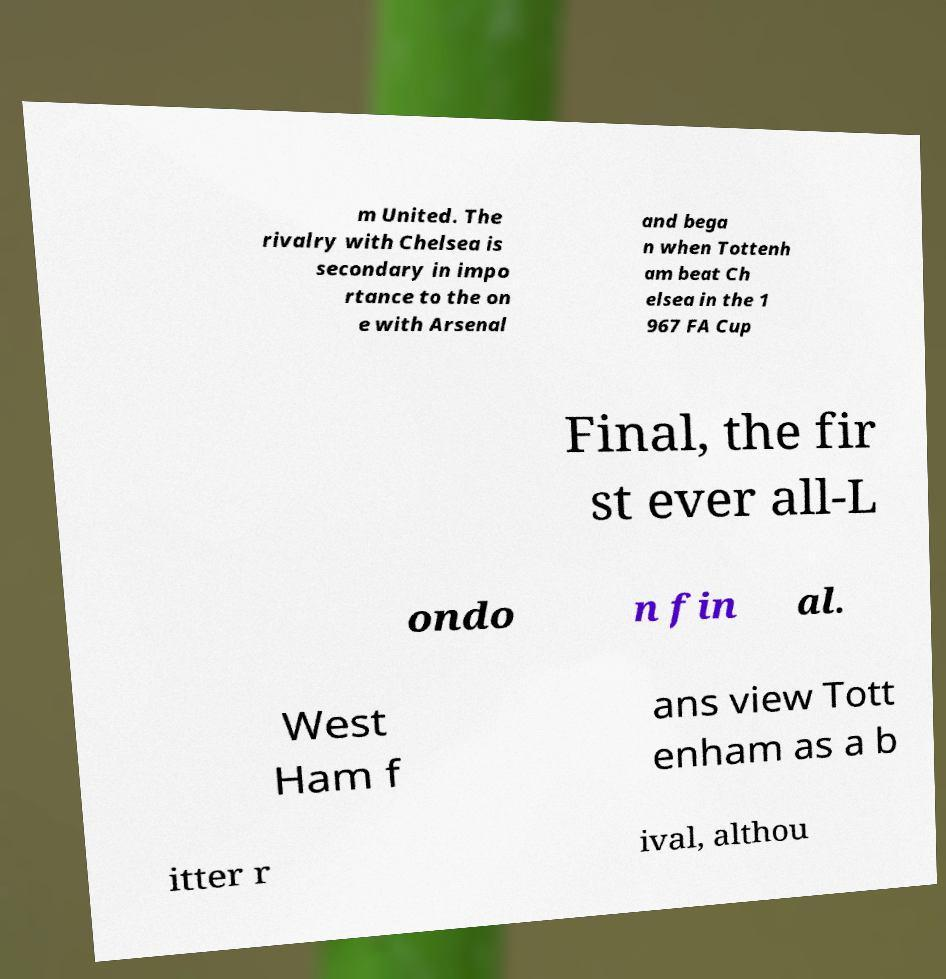What messages or text are displayed in this image? I need them in a readable, typed format. m United. The rivalry with Chelsea is secondary in impo rtance to the on e with Arsenal and bega n when Tottenh am beat Ch elsea in the 1 967 FA Cup Final, the fir st ever all-L ondo n fin al. West Ham f ans view Tott enham as a b itter r ival, althou 